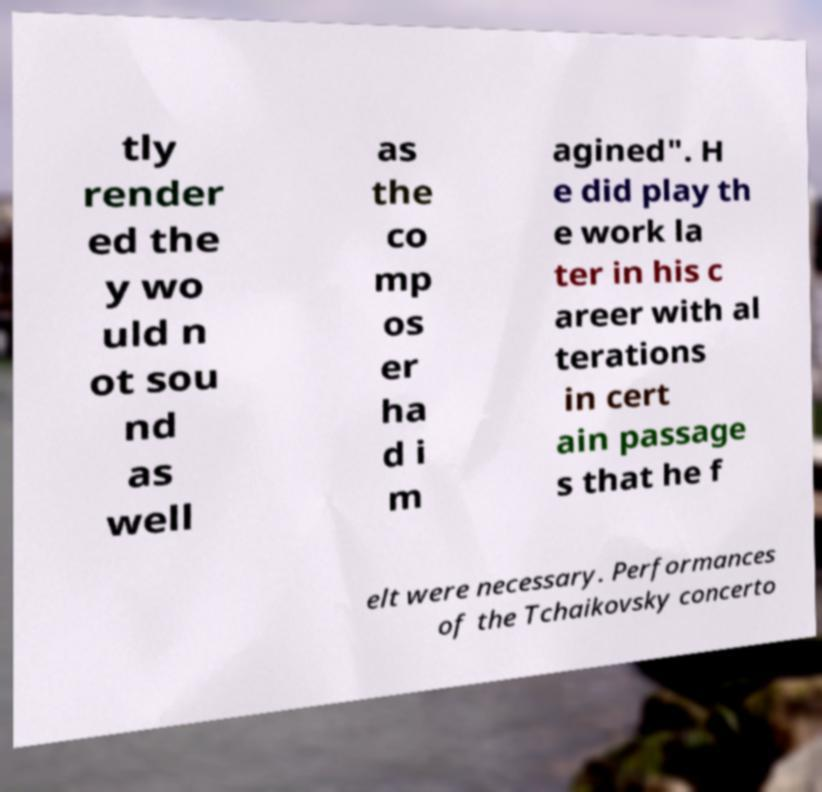For documentation purposes, I need the text within this image transcribed. Could you provide that? tly render ed the y wo uld n ot sou nd as well as the co mp os er ha d i m agined". H e did play th e work la ter in his c areer with al terations in cert ain passage s that he f elt were necessary. Performances of the Tchaikovsky concerto 